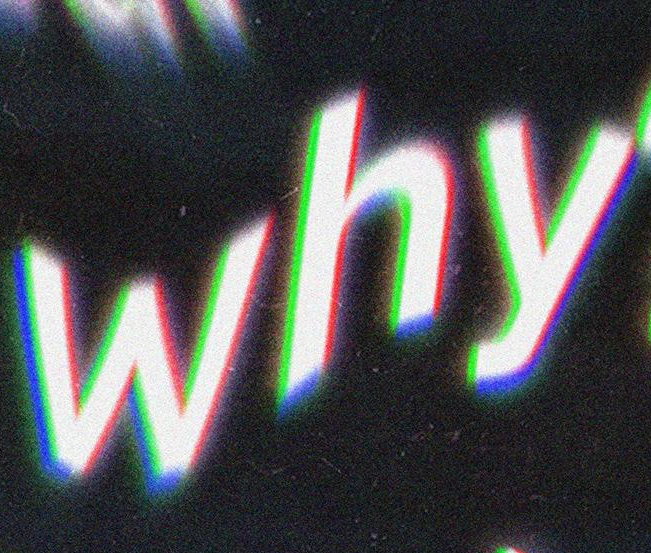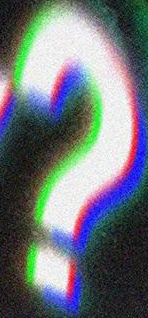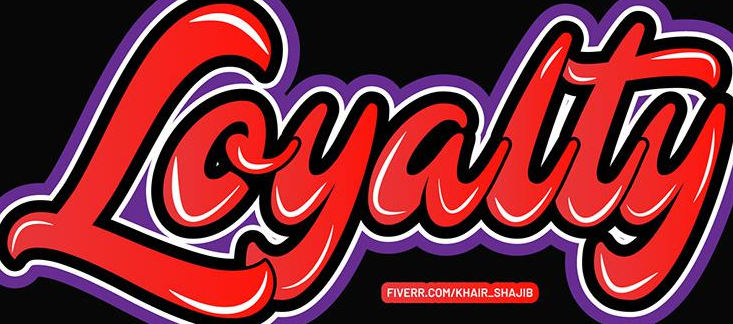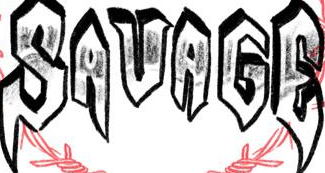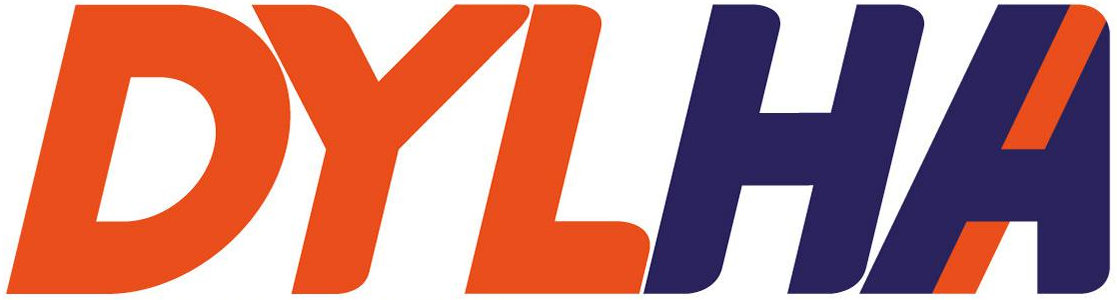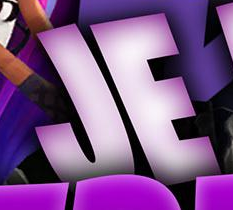Read the text from these images in sequence, separated by a semicolon. why; ?; Loyalty; SAVAGE; DYLHA; JE 